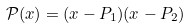Convert formula to latex. <formula><loc_0><loc_0><loc_500><loc_500>\mathcal { P } ( x ) = ( x - P _ { 1 } ) ( x - P _ { 2 } )</formula> 